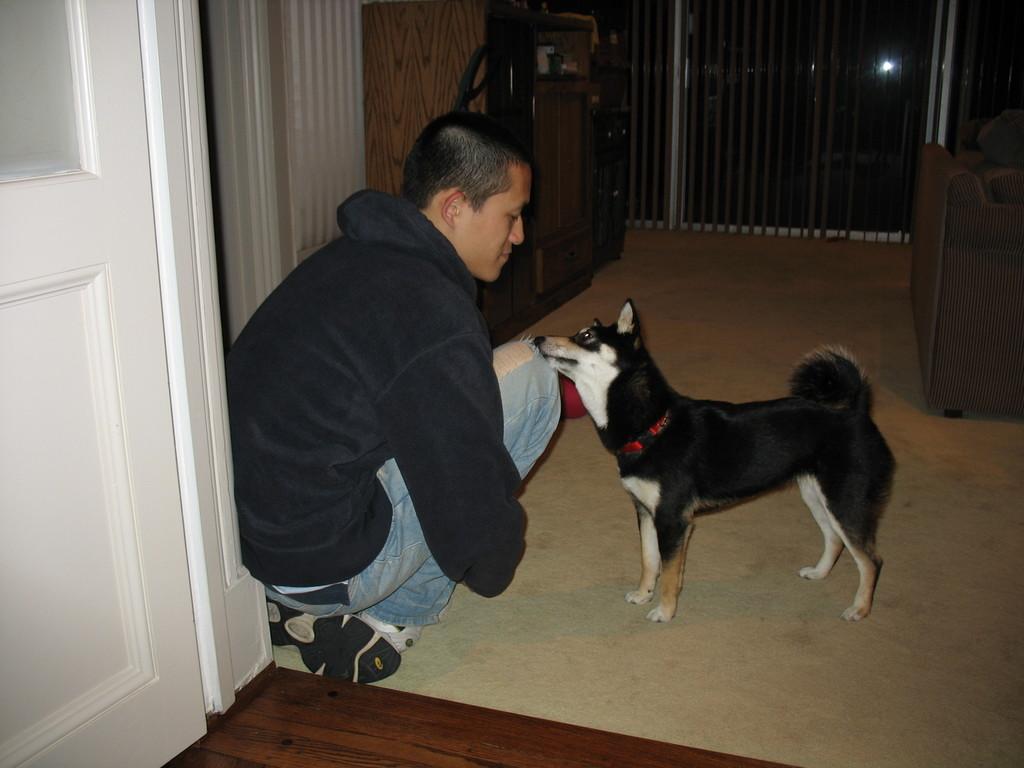Could you give a brief overview of what you see in this image? In this image there is a dog and in front of the dog there is a person, behind the person there is a door. In the background there is a wall, in front of the wall there is a table and on the right side of the image there is a sofa. At the bottom of the image there is a floor. 